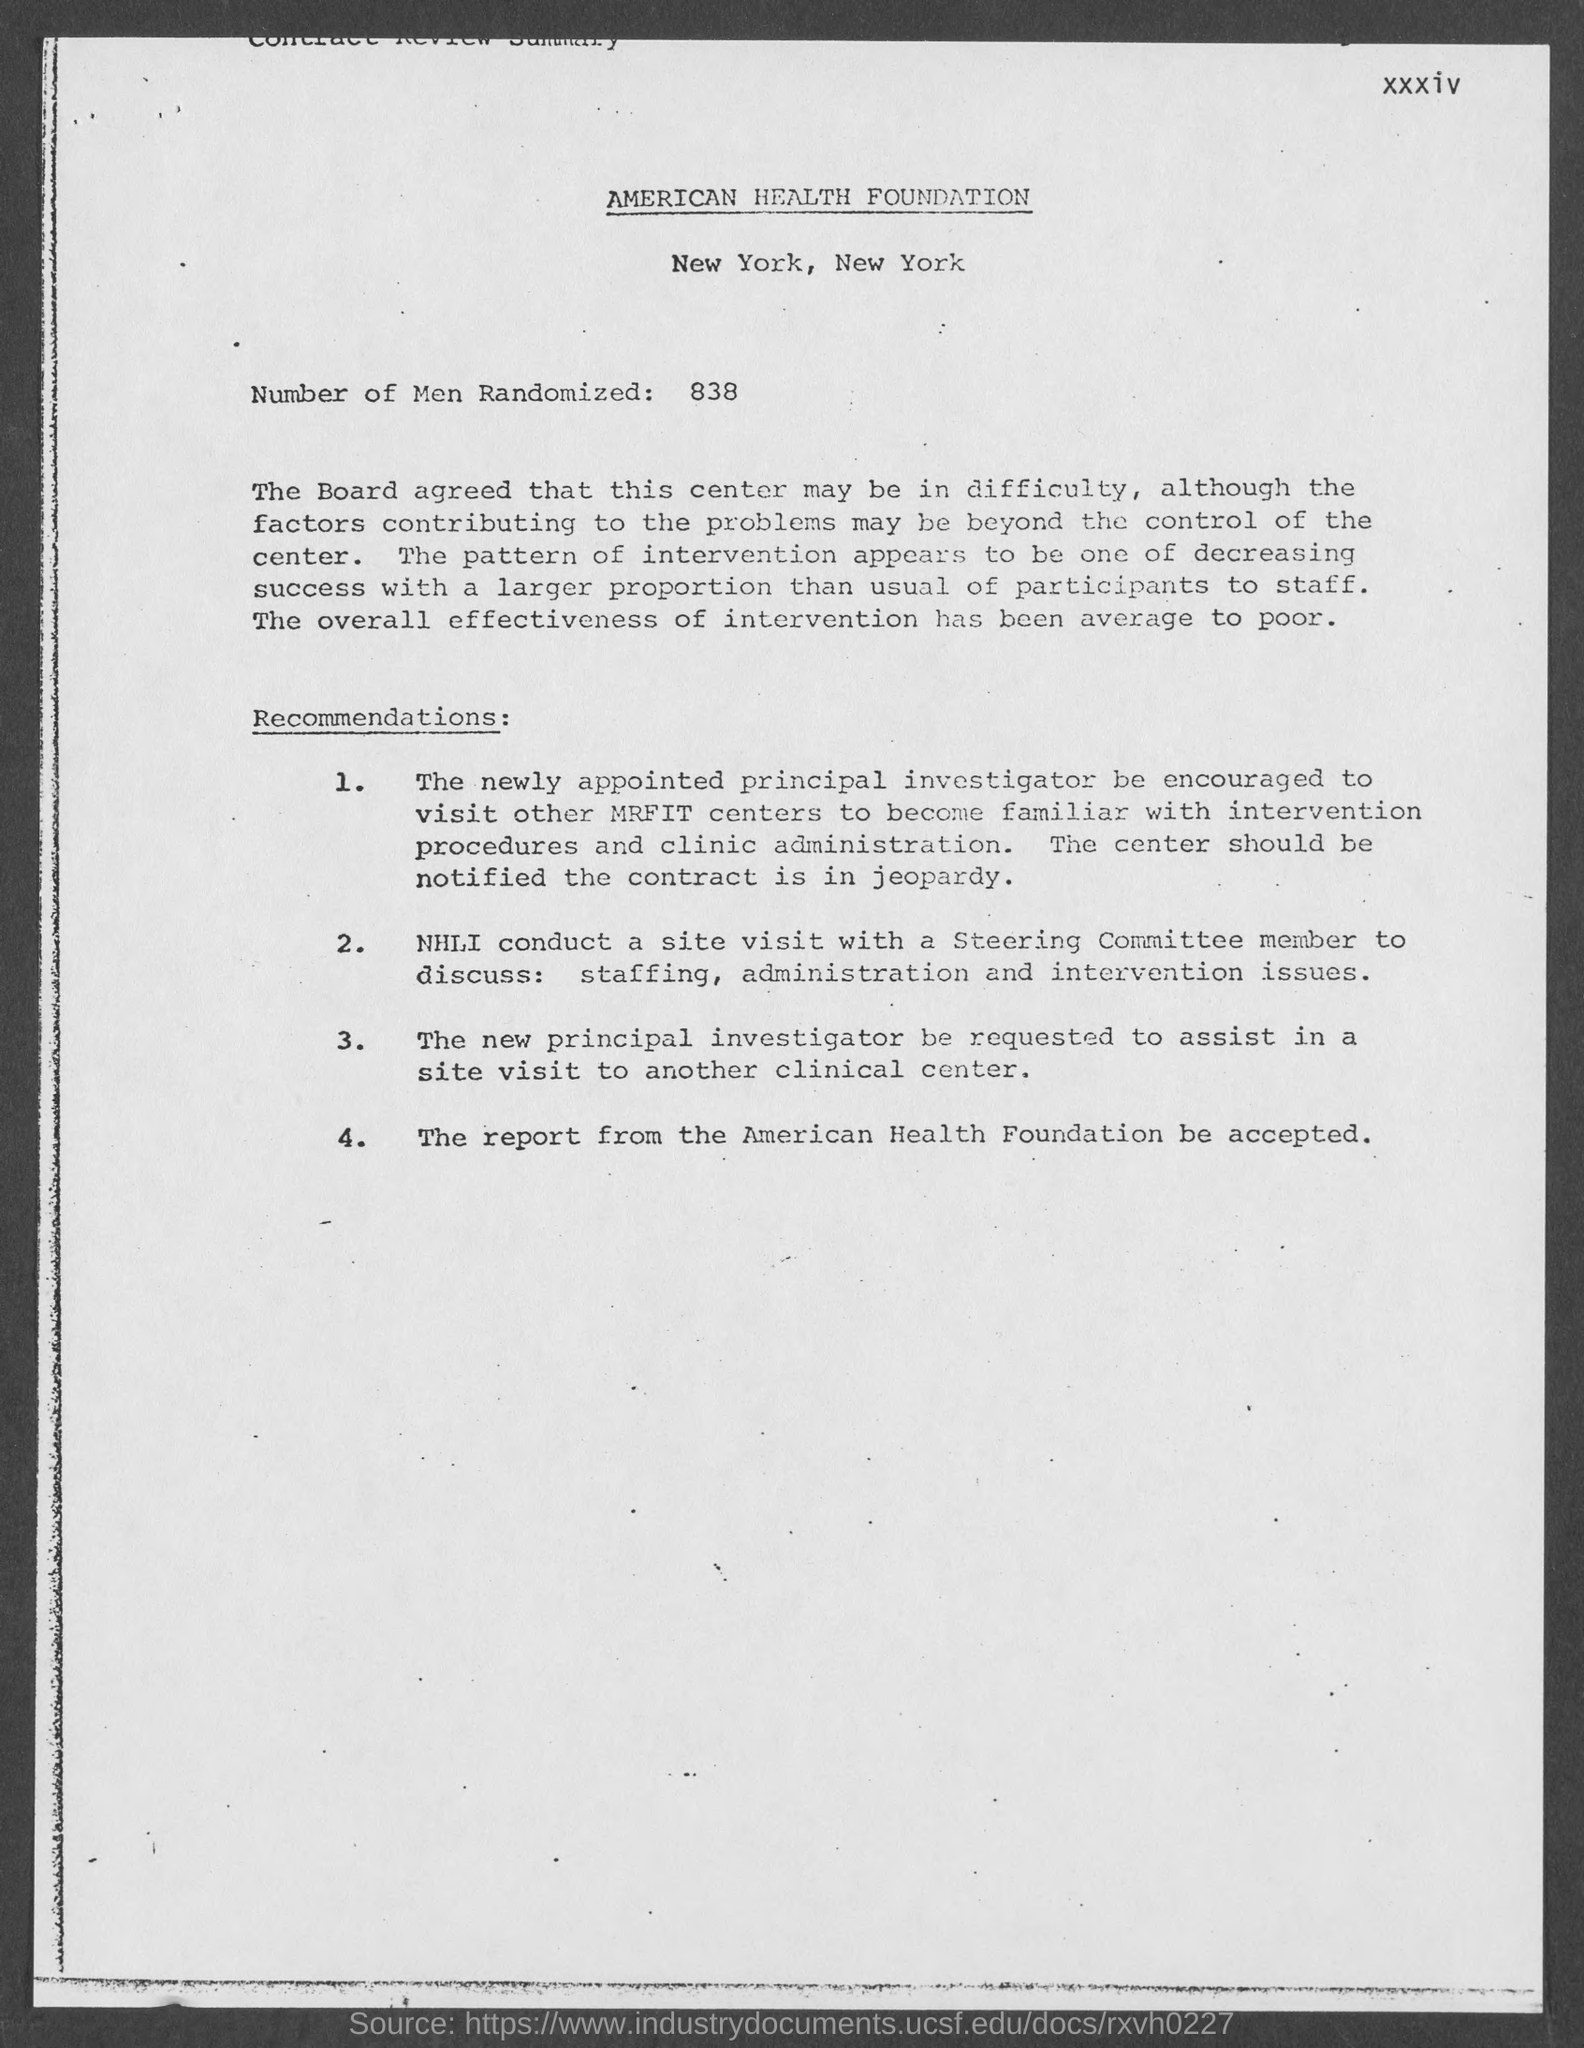How many number of men are randomized ?
Offer a terse response. 838. 